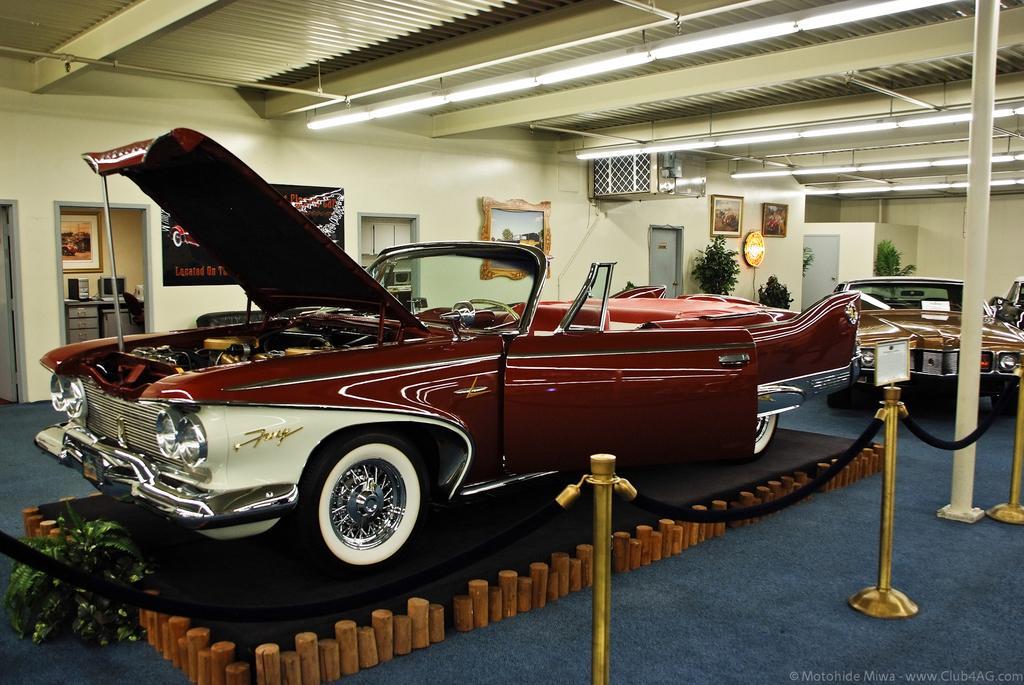How would you summarize this image in a sentence or two? In this image there is a car on the floor. It is surrounded by the fence. Right side there is a pole. Behind there are few vehicles on the floor. Behind there are few plants. Few picture frames are attached to the wall having few doors. Left side there is a door. Behind it there is a table having a monitor and CPU on it. Top of the image few lights are attached to the roof. 